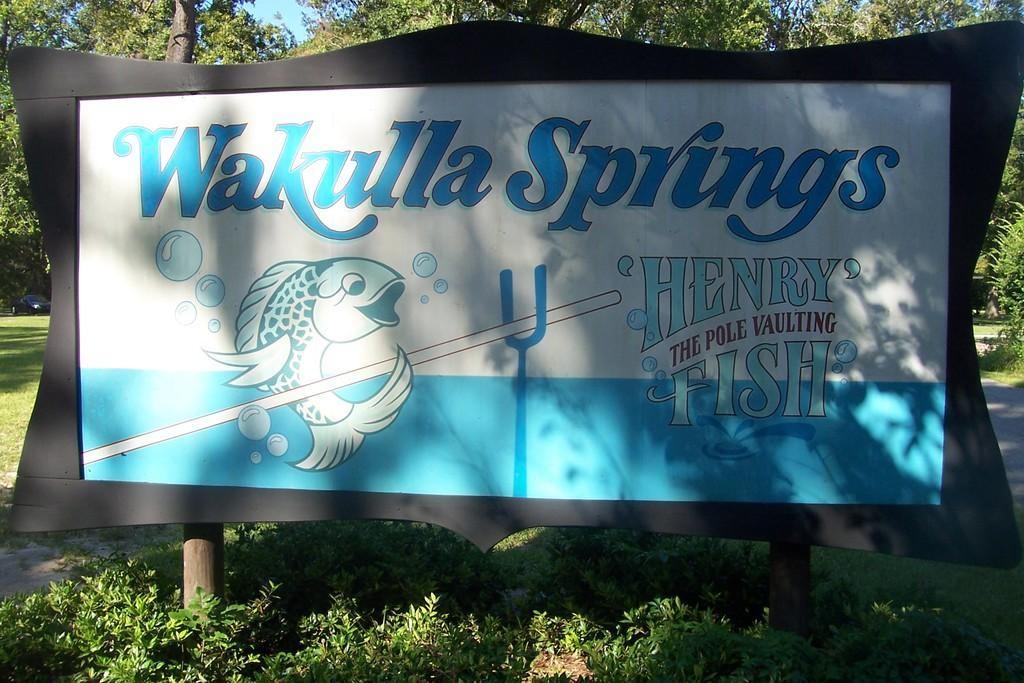In one or two sentences, can you explain what this image depicts? In the center of the picture there is a board. At the bottom there are plants. In the background there are trees, grass and a car. 